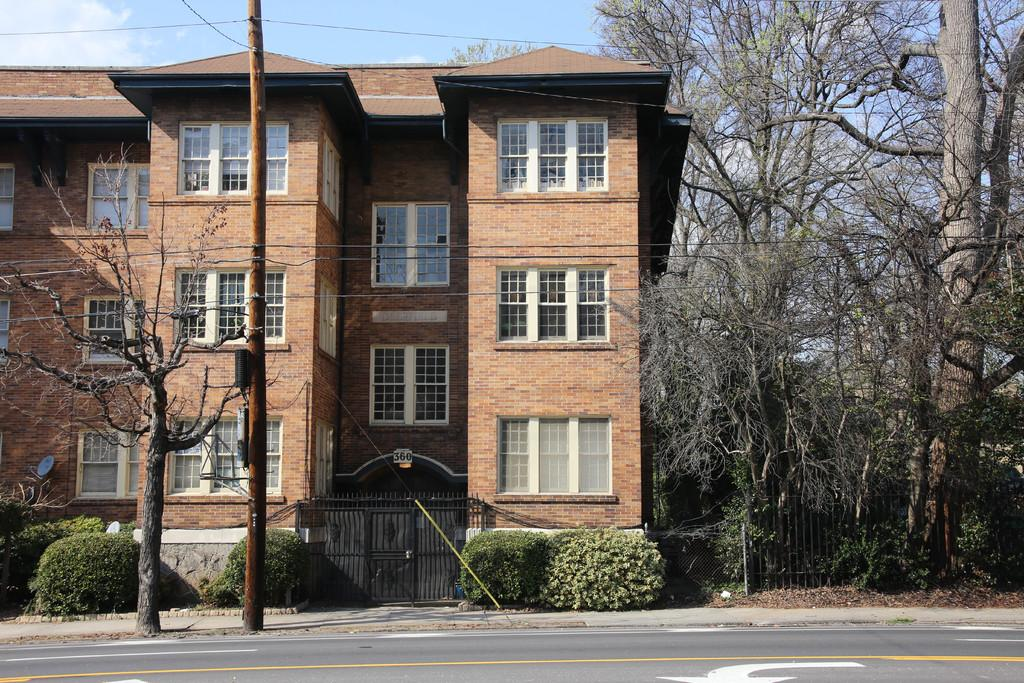What is the main feature of the image? There is a road in the image. What is located beside the road? There is a building beside the road. What type of vegetation can be seen in the image? Trees and plants are present in the image. What structure can be seen in the image? There is a pole in the image. What else is visible in the image besides the road, building, trees, plants, and pole? There are other objects in the image. What is visible in the background of the image? The sky is visible in the background, and clouds are present in the sky. What is the fact about the comparison of death in the image? There is no mention of death or comparison in the image, as it primarily features a road, building, trees, plants, pole, and other objects. 